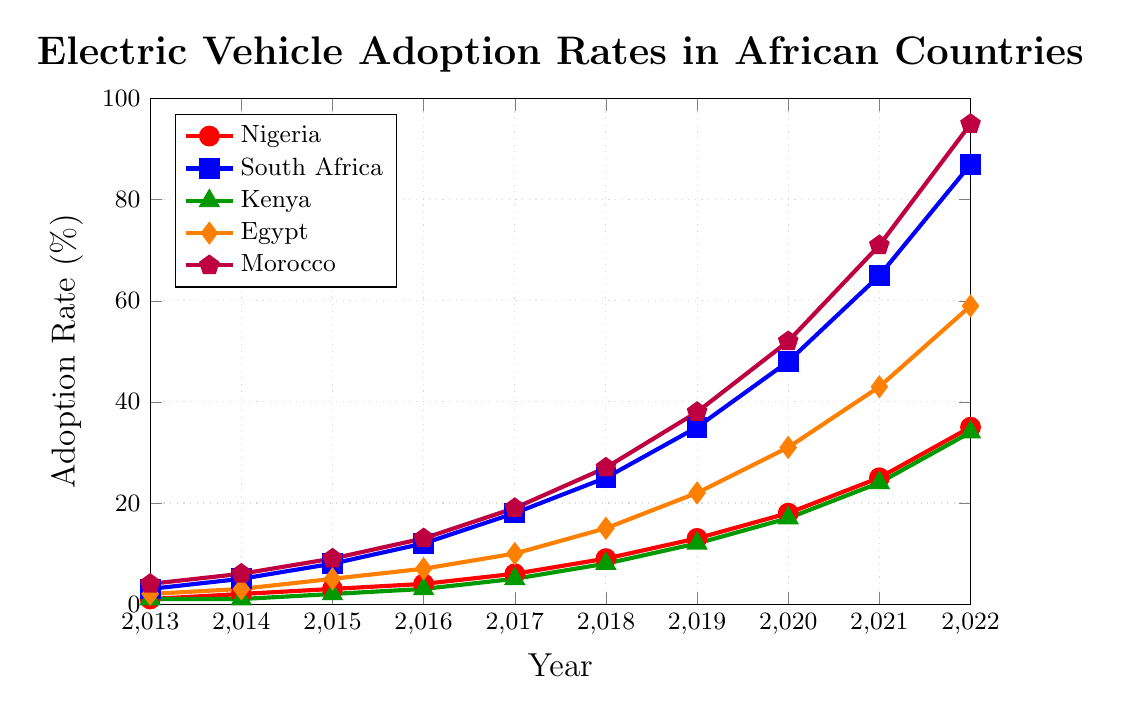Which country has the highest electric vehicle adoption rate in 2022? In 2022, observe the data points for each country and identify the highest one. Morocco's data point (0.95) is the highest among all.
Answer: Morocco Which two years had the most significant increase in electric vehicle adoption rates for Nigeria? Compare the adoption rates year-over-year for Nigeria, identifying the years with the highest absolute differences. 2021-2022 (0.35 - 0.25 = 0.1) and 2020-2021 (0.25 - 0.18 = 0.07) show the most significant increases.
Answer: 2021-2022, 2020-2021 Between South Africa and Kenya, which country saw a higher adoption rate in 2018? Compare the 2018 adoption rates for South Africa and Kenya. South Africa (0.25) had a higher rate than Kenya (0.08).
Answer: South Africa What is the average adoption rate of electric vehicles in Egypt over the decade? Sum the yearly adoption rates for Egypt from 2013 to 2022 and divide by 10. (0.02 + 0.03 + 0.05 + 0.07 + 0.10 + 0.15 + 0.22 + 0.31 + 0.43 + 0.59) = 1.97; 1.97 / 10 = 0.197
Answer: 0.197 In which year did Morocco surpass the 50% adoption rate? Examine the adoption rates for Morocco year by year and identify the first year it exceeds 0.50. It is in 2020 (0.52).
Answer: 2020 How much did the adoption rate in Kenya increase from 2016 to 2019? Subtract Kenya's 2016 rate from the 2019 rate. 0.12 - 0.03 = 0.09.
Answer: 0.09 Which country had the lowest adoption rate in 2015? Compare the 2015 adoption rates for all countries and identify the lowest one. Kenya at 0.02 has the lowest rate.
Answer: Kenya What is the total increase in adoption rate for South Africa from 2013 to 2022? Subtract South Africa's 2013 rate from 2022 rate. 0.87 - 0.03 = 0.84
Answer: 0.84 Compare the rates of Morocco and Egypt in 2021. Which country has a higher adoption rate, and by how much? Examine 2021 rates for Morocco and Egypt and find the difference. Morocco (0.71) - Egypt (0.43) = 0.28.
Answer: Morocco by 0.28 What was the growth rate of electric vehicle adoption in Nigeria from 2017 to 2018? Calculate the difference between 2018 and 2017 rates for Nigeria, then divide by the 2017 rate and multiply by 100. ((0.09 - 0.06) / 0.06) * 100 = 50%
Answer: 50% 